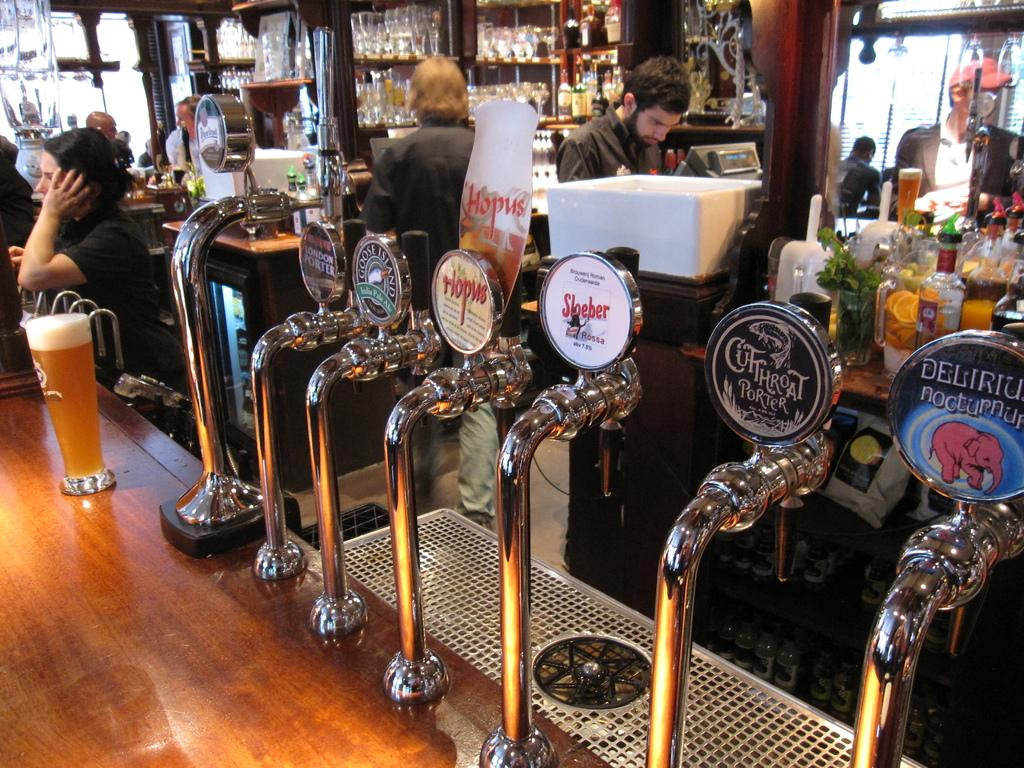<image>
Relay a brief, clear account of the picture shown. The black colored second to last right tap says "Cutthroat Porter" on it. 